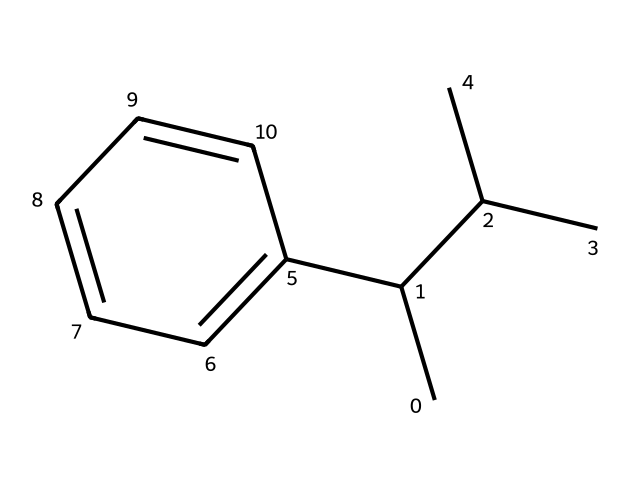What is the base carbon structure of this polystyrene? The structure reveals a benzene ring (cyclohexane), indicated by the alternating double bonds and the fact that it is surrounded by carbon atoms, showing it is part of an aromatic compound. This is a key part of the polystyrene structure.
Answer: benzene How many carbon atoms are present in the chemical structure? By counting the carbon atoms in the provided SMILES representation, we see there are a total of 10 carbon atoms in the entire molecule: three from the branched chain and seven from the benzene ring.
Answer: 10 What is the type of chemical bonding predominant in polystyrene? The structure exhibits single bonds primarily between carbon atoms, with carbon-carbon and carbon-hydrogen being the common types of bonding present in organic compounds like polystyrene.
Answer: covalent Which functional group is indicated in the structure? Upon examining the SMILES and considering typical functional groups, there is no distinct functional group (like hydroxyl or carboxyl) as it is primarily composed of hydrocarbons without modifications.
Answer: none What property of polystyrene allows it to be used for disposable food containers? The chemical structure, featuring a stable, lightweight, and rigid arrangement of carbon atoms, results in physical properties like thermal insulation and low permeability, which make it suitable for food containers.
Answer: stability How does the presence of the benzene ring influence the properties of polystyrene? The presence of the benzene ring contributes to the rigidity and resistance to degradation of polystyrene, due to its aromatic characteristics and electronic stability, which enhances its utility in various applications.
Answer: rigidity What is the molecular weight range of typical polystyrene? Polystyrene typically has a molecular weight ranging from 50,000 to 400,000 g/mol, which is inferred from its carbon composition and repeating units in its polymer structure.
Answer: 50,000 to 400,000 